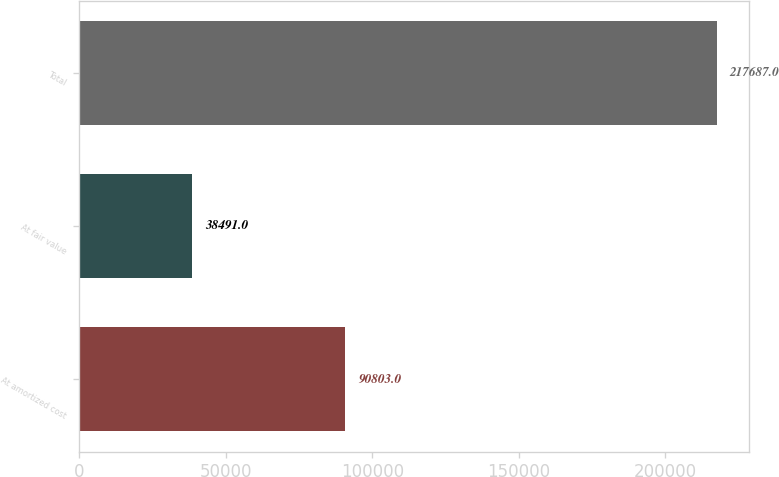<chart> <loc_0><loc_0><loc_500><loc_500><bar_chart><fcel>At amortized cost<fcel>At fair value<fcel>Total<nl><fcel>90803<fcel>38491<fcel>217687<nl></chart> 